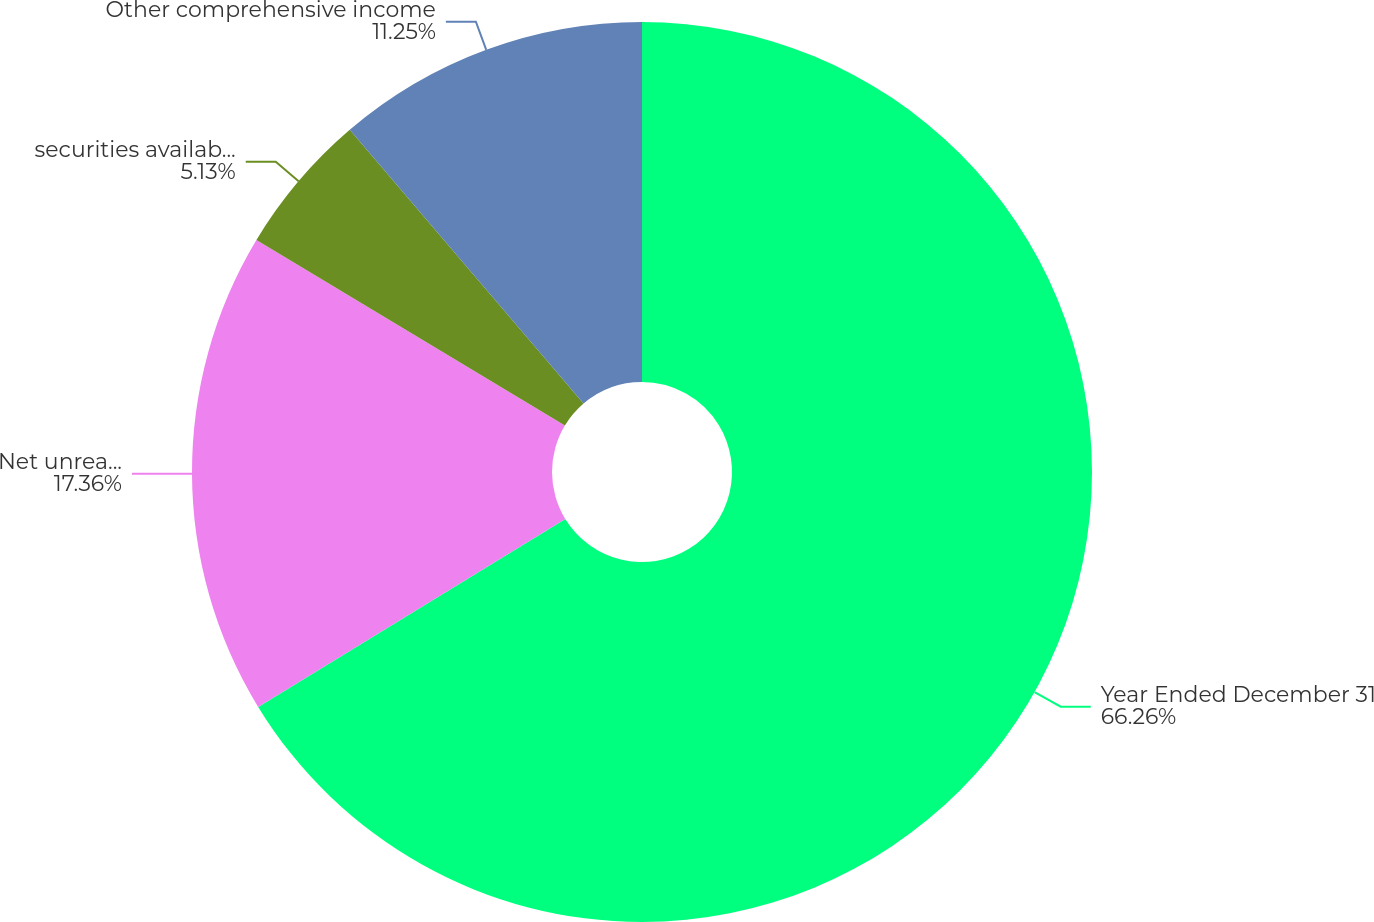Convert chart. <chart><loc_0><loc_0><loc_500><loc_500><pie_chart><fcel>Year Ended December 31<fcel>Net unrealized gain (loss)<fcel>securities available for sale<fcel>Other comprehensive income<nl><fcel>66.26%<fcel>17.36%<fcel>5.13%<fcel>11.25%<nl></chart> 